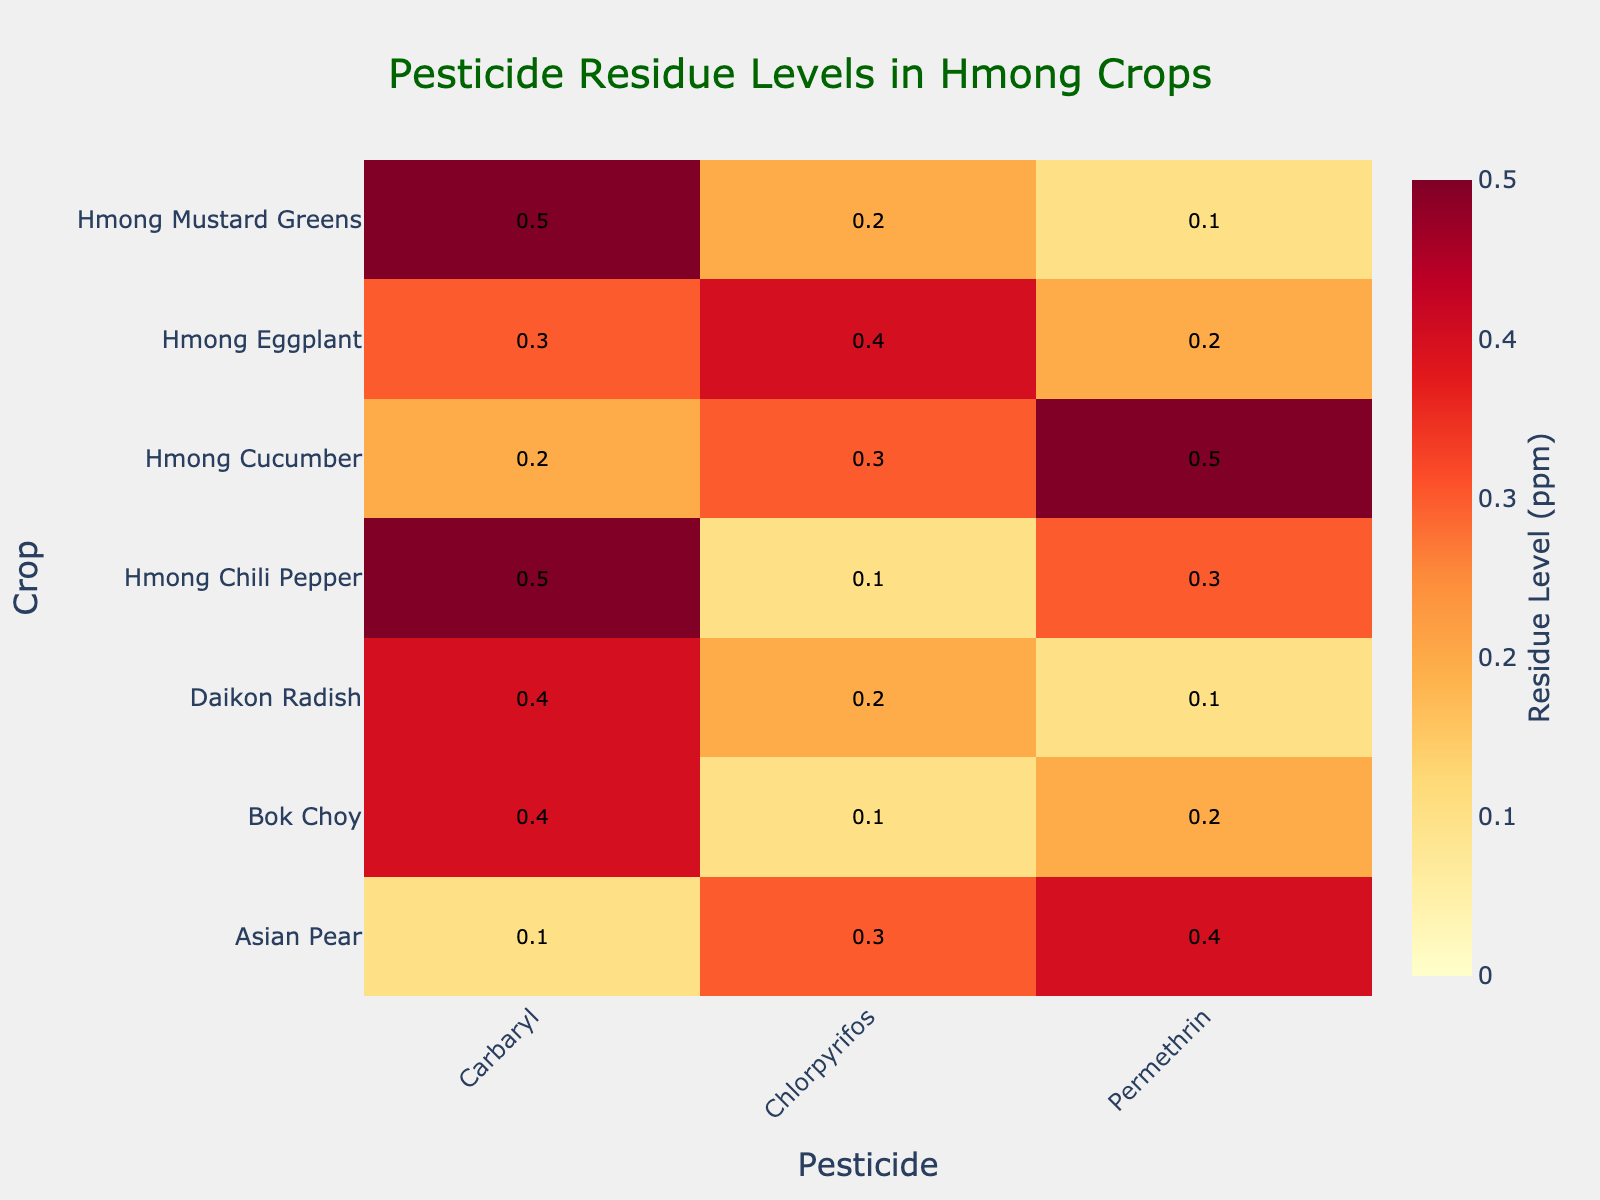what is the title of the heatmap? The title is located at the top of the heatmap, centered and typically in a larger and bolder font. It provides a succinct summary of the data presented. In this case, it reads "Pesticide Residue Levels in Hmong Crops".
Answer: Pesticide Residue Levels in Hmong Crops Which crop has the highest residue level for Carbaryl? To answer this, look at the column labeled "Carbaryl" in the heatmap and identify the crop with the highest value. Hmong Mustard Greens and Hmong Chili Pepper both show the highest residue level of 0.5 ppm.
Answer: Hmong Mustard Greens and Hmong Chili Pepper Which crop has the lowest residue level overall? Examine all rows to find the lowest individual value in the heatmap. Asian Pear has the lowest residue level of 0.1 ppm for Carbaryl.
Answer: Asian Pear What is the average residue level of Permethrin across all crops? To calculate the average, add the Permethrin residue levels for all crops: 0.2 (Bok Choy) + 0.1 (Hmong Mustard Greens) + 0.5 (Hmong Cucumber) + 0.2 (Hmong Eggplant) + 0.4 (Asian Pear) + 0.1 (Daikon Radish) + 0.3 (Hmong Chili Pepper) = 1.8, then divide by the number of crops, which is 7. The average is 1.8/7 = 0.257 ppm.
Answer: 0.257 ppm Which pesticide shows the highest residue level in Hmong Eggplant? Look at the row for Hmong Eggplant and compare the values for each pesticide. The highest residue level for Hmong Eggplant is given by Chlorpyrifos at 0.4 ppm.
Answer: Chlorpyrifos Which crop has the most diverse range of residue levels across different pesticides? Identify by finding the crop that has the greatest difference between its highest and lowest residue levels among pesticides. Hmong Eggplant has the most diverse range with levels from 0.2 to 0.4 ppm (0.4 - 0.2 = 0.2).
Answer: Hmong Eggplant Are there any crops with residue levels of 0.4 ppm for multiple pesticides? Check for crops that have a value of 0.4 ppm in more than one pesticide column. Bok Choy has 0.4 ppm in Carbaryl and Daikon Radish has 0.4 ppm in Carbaryl.
Answer: Bok Choy and Daikon Radish Which pesticide tends to have the highest residue levels across most crops? Look at the columns and compare the overall trend. Carbaryl seems to have relatively high residue levels across several crops, with multiple values of 0.4 and 0.5 ppm.
Answer: Carbaryl How does the residue level of Chlorpyrifos in Hmong Mustard Greens compare to Hmong Cucumber? Locate the Chlorpyrifos column and compare the values for Hmong Mustard Greens and Hmong Cucumber. The residue level for Hmong Mustard Greens is 0.2 ppm and for Hmong Cucumber is 0.3 ppm. Hmong Cucumber has a higher level.
Answer: Hmong Cucumber 